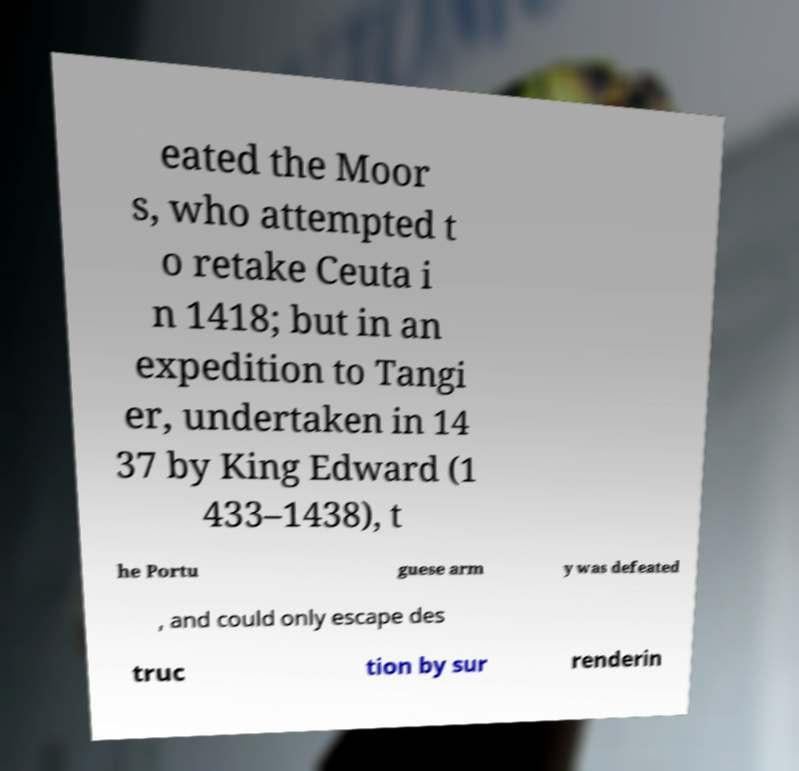Please read and relay the text visible in this image. What does it say? eated the Moor s, who attempted t o retake Ceuta i n 1418; but in an expedition to Tangi er, undertaken in 14 37 by King Edward (1 433–1438), t he Portu guese arm y was defeated , and could only escape des truc tion by sur renderin 